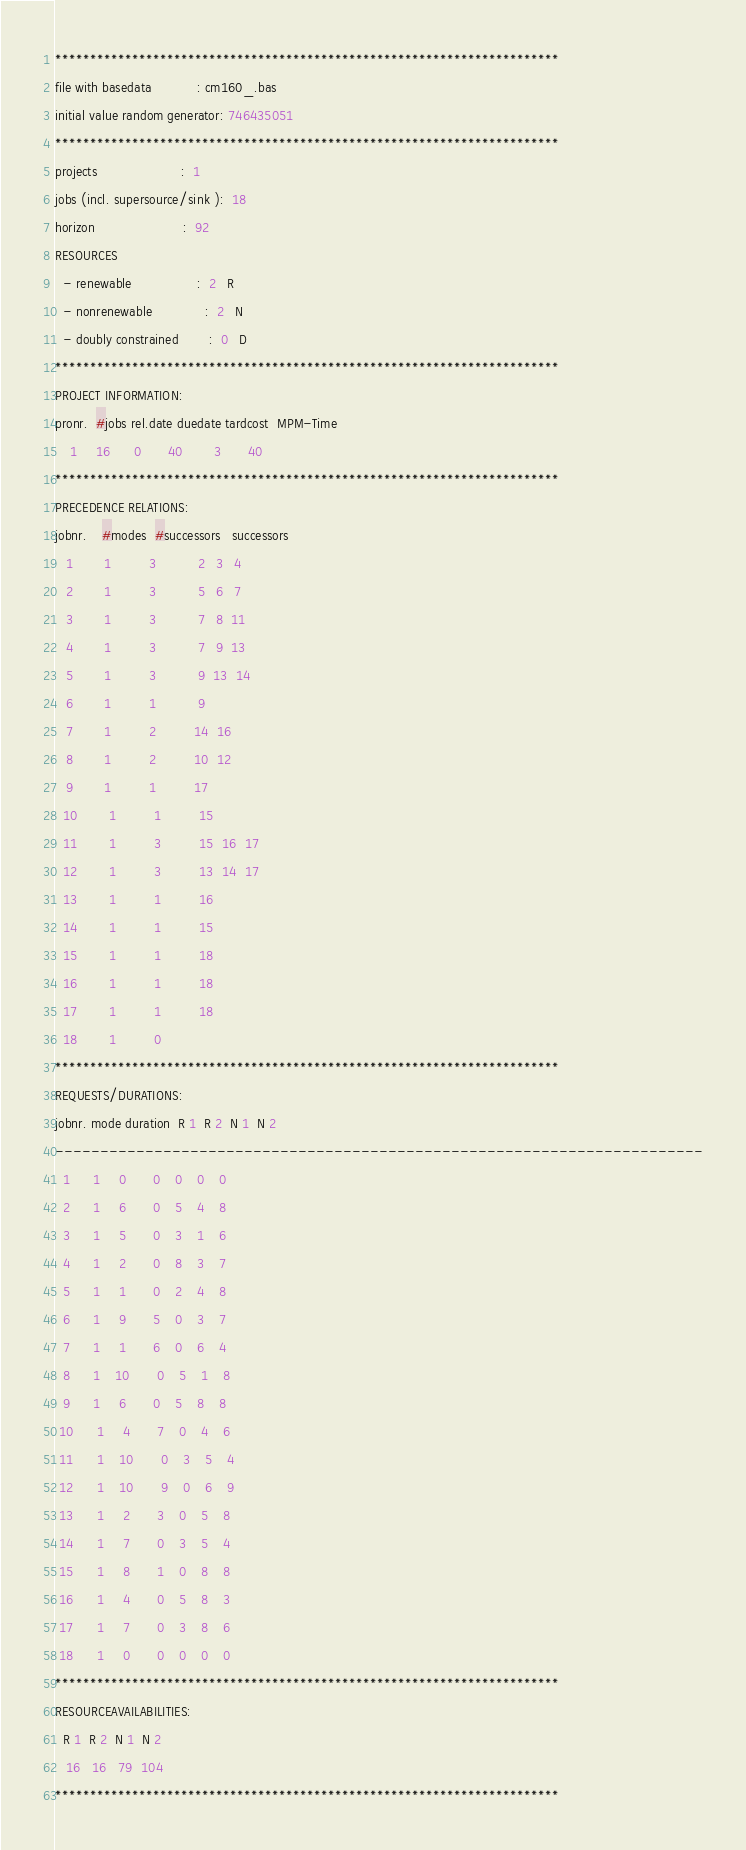<code> <loc_0><loc_0><loc_500><loc_500><_ObjectiveC_>************************************************************************
file with basedata            : cm160_.bas
initial value random generator: 746435051
************************************************************************
projects                      :  1
jobs (incl. supersource/sink ):  18
horizon                       :  92
RESOURCES
  - renewable                 :  2   R
  - nonrenewable              :  2   N
  - doubly constrained        :  0   D
************************************************************************
PROJECT INFORMATION:
pronr.  #jobs rel.date duedate tardcost  MPM-Time
    1     16      0       40        3       40
************************************************************************
PRECEDENCE RELATIONS:
jobnr.    #modes  #successors   successors
   1        1          3           2   3   4
   2        1          3           5   6   7
   3        1          3           7   8  11
   4        1          3           7   9  13
   5        1          3           9  13  14
   6        1          1           9
   7        1          2          14  16
   8        1          2          10  12
   9        1          1          17
  10        1          1          15
  11        1          3          15  16  17
  12        1          3          13  14  17
  13        1          1          16
  14        1          1          15
  15        1          1          18
  16        1          1          18
  17        1          1          18
  18        1          0        
************************************************************************
REQUESTS/DURATIONS:
jobnr. mode duration  R 1  R 2  N 1  N 2
------------------------------------------------------------------------
  1      1     0       0    0    0    0
  2      1     6       0    5    4    8
  3      1     5       0    3    1    6
  4      1     2       0    8    3    7
  5      1     1       0    2    4    8
  6      1     9       5    0    3    7
  7      1     1       6    0    6    4
  8      1    10       0    5    1    8
  9      1     6       0    5    8    8
 10      1     4       7    0    4    6
 11      1    10       0    3    5    4
 12      1    10       9    0    6    9
 13      1     2       3    0    5    8
 14      1     7       0    3    5    4
 15      1     8       1    0    8    8
 16      1     4       0    5    8    3
 17      1     7       0    3    8    6
 18      1     0       0    0    0    0
************************************************************************
RESOURCEAVAILABILITIES:
  R 1  R 2  N 1  N 2
   16   16   79  104
************************************************************************
</code> 